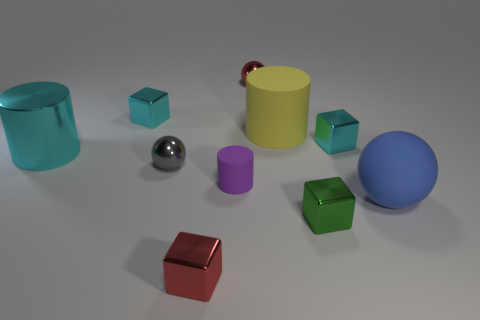Does the small cyan object that is right of the small red sphere have the same material as the big cylinder that is behind the large cyan metallic object?
Your response must be concise. No. What is the shape of the red object in front of the sphere behind the large cyan cylinder?
Make the answer very short. Cube. There is a ball that is made of the same material as the tiny purple cylinder; what color is it?
Offer a terse response. Blue. Is the large metallic thing the same color as the small matte thing?
Provide a short and direct response. No. What shape is the blue object that is the same size as the yellow matte cylinder?
Provide a succinct answer. Sphere. What is the size of the yellow matte cylinder?
Your response must be concise. Large. Is the size of the red metallic thing that is to the right of the small red block the same as the red shiny thing in front of the big blue object?
Your answer should be compact. Yes. What is the color of the big matte thing that is behind the large rubber thing to the right of the small green thing?
Ensure brevity in your answer.  Yellow. What material is the gray thing that is the same size as the purple matte object?
Keep it short and to the point. Metal. What number of metallic things are either small cylinders or cubes?
Keep it short and to the point. 4. 